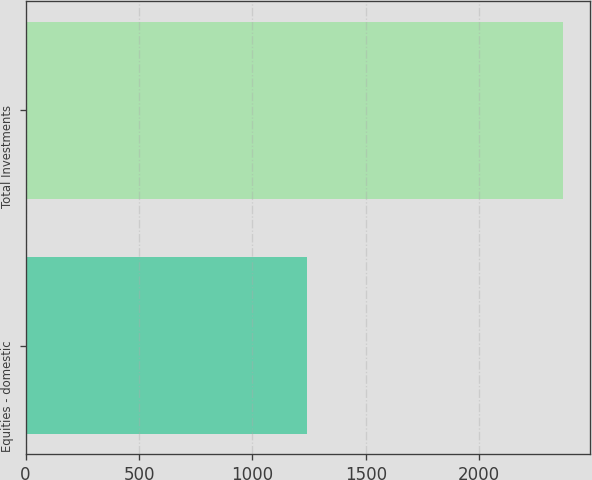Convert chart. <chart><loc_0><loc_0><loc_500><loc_500><bar_chart><fcel>Equities - domestic<fcel>Total Investments<nl><fcel>1241<fcel>2371<nl></chart> 